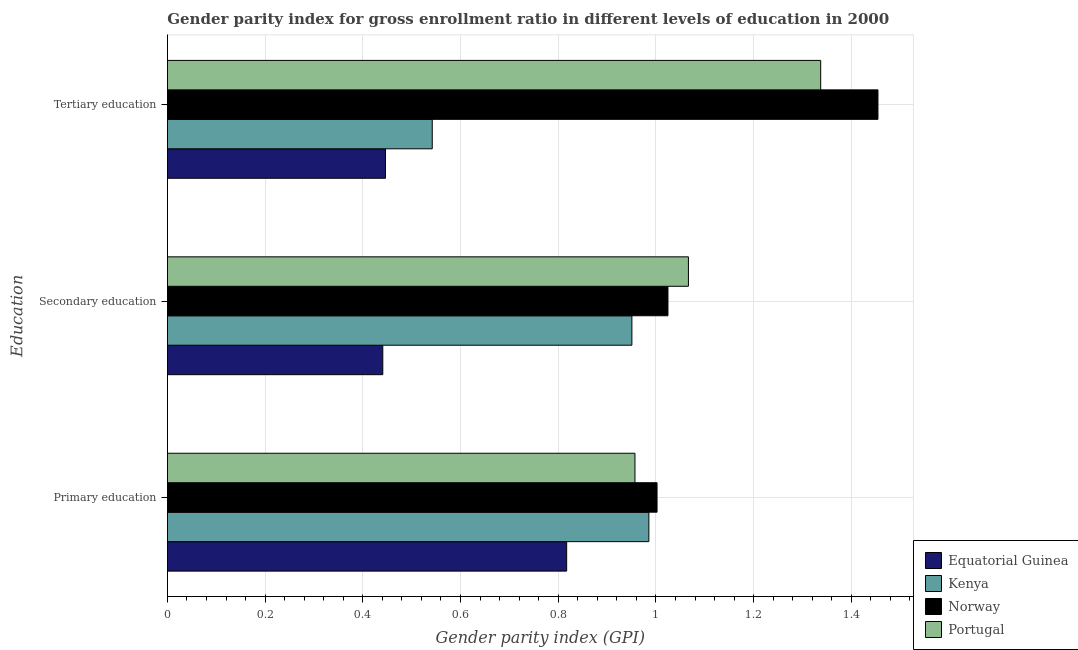How many different coloured bars are there?
Keep it short and to the point. 4. How many groups of bars are there?
Keep it short and to the point. 3. Are the number of bars per tick equal to the number of legend labels?
Keep it short and to the point. Yes. Are the number of bars on each tick of the Y-axis equal?
Keep it short and to the point. Yes. How many bars are there on the 1st tick from the top?
Your answer should be compact. 4. How many bars are there on the 1st tick from the bottom?
Provide a succinct answer. 4. What is the label of the 1st group of bars from the top?
Offer a very short reply. Tertiary education. What is the gender parity index in tertiary education in Portugal?
Provide a short and direct response. 1.34. Across all countries, what is the maximum gender parity index in tertiary education?
Offer a very short reply. 1.45. Across all countries, what is the minimum gender parity index in tertiary education?
Offer a very short reply. 0.45. In which country was the gender parity index in secondary education maximum?
Your response must be concise. Portugal. In which country was the gender parity index in primary education minimum?
Your answer should be compact. Equatorial Guinea. What is the total gender parity index in tertiary education in the graph?
Ensure brevity in your answer.  3.78. What is the difference between the gender parity index in primary education in Equatorial Guinea and that in Portugal?
Ensure brevity in your answer.  -0.14. What is the difference between the gender parity index in tertiary education in Kenya and the gender parity index in primary education in Norway?
Give a very brief answer. -0.46. What is the average gender parity index in secondary education per country?
Your response must be concise. 0.87. What is the difference between the gender parity index in secondary education and gender parity index in tertiary education in Portugal?
Keep it short and to the point. -0.27. What is the ratio of the gender parity index in primary education in Portugal to that in Norway?
Offer a terse response. 0.95. Is the gender parity index in secondary education in Norway less than that in Kenya?
Your response must be concise. No. What is the difference between the highest and the second highest gender parity index in primary education?
Make the answer very short. 0.02. What is the difference between the highest and the lowest gender parity index in primary education?
Your answer should be compact. 0.19. In how many countries, is the gender parity index in primary education greater than the average gender parity index in primary education taken over all countries?
Your answer should be compact. 3. Is the sum of the gender parity index in tertiary education in Norway and Equatorial Guinea greater than the maximum gender parity index in secondary education across all countries?
Offer a very short reply. Yes. What does the 4th bar from the top in Secondary education represents?
Make the answer very short. Equatorial Guinea. What does the 4th bar from the bottom in Primary education represents?
Ensure brevity in your answer.  Portugal. How many bars are there?
Your response must be concise. 12. How many countries are there in the graph?
Provide a short and direct response. 4. What is the difference between two consecutive major ticks on the X-axis?
Give a very brief answer. 0.2. Are the values on the major ticks of X-axis written in scientific E-notation?
Ensure brevity in your answer.  No. Does the graph contain any zero values?
Keep it short and to the point. No. Does the graph contain grids?
Your response must be concise. Yes. How many legend labels are there?
Keep it short and to the point. 4. What is the title of the graph?
Make the answer very short. Gender parity index for gross enrollment ratio in different levels of education in 2000. What is the label or title of the X-axis?
Provide a succinct answer. Gender parity index (GPI). What is the label or title of the Y-axis?
Ensure brevity in your answer.  Education. What is the Gender parity index (GPI) of Equatorial Guinea in Primary education?
Keep it short and to the point. 0.82. What is the Gender parity index (GPI) of Kenya in Primary education?
Offer a terse response. 0.99. What is the Gender parity index (GPI) in Norway in Primary education?
Provide a short and direct response. 1. What is the Gender parity index (GPI) of Portugal in Primary education?
Keep it short and to the point. 0.96. What is the Gender parity index (GPI) of Equatorial Guinea in Secondary education?
Offer a terse response. 0.44. What is the Gender parity index (GPI) of Kenya in Secondary education?
Ensure brevity in your answer.  0.95. What is the Gender parity index (GPI) of Norway in Secondary education?
Provide a short and direct response. 1.02. What is the Gender parity index (GPI) in Portugal in Secondary education?
Provide a short and direct response. 1.07. What is the Gender parity index (GPI) in Equatorial Guinea in Tertiary education?
Your response must be concise. 0.45. What is the Gender parity index (GPI) of Kenya in Tertiary education?
Provide a succinct answer. 0.54. What is the Gender parity index (GPI) of Norway in Tertiary education?
Your response must be concise. 1.45. What is the Gender parity index (GPI) in Portugal in Tertiary education?
Your answer should be compact. 1.34. Across all Education, what is the maximum Gender parity index (GPI) of Equatorial Guinea?
Ensure brevity in your answer.  0.82. Across all Education, what is the maximum Gender parity index (GPI) of Kenya?
Ensure brevity in your answer.  0.99. Across all Education, what is the maximum Gender parity index (GPI) of Norway?
Give a very brief answer. 1.45. Across all Education, what is the maximum Gender parity index (GPI) in Portugal?
Ensure brevity in your answer.  1.34. Across all Education, what is the minimum Gender parity index (GPI) in Equatorial Guinea?
Provide a short and direct response. 0.44. Across all Education, what is the minimum Gender parity index (GPI) in Kenya?
Provide a short and direct response. 0.54. Across all Education, what is the minimum Gender parity index (GPI) in Norway?
Your answer should be compact. 1. Across all Education, what is the minimum Gender parity index (GPI) of Portugal?
Give a very brief answer. 0.96. What is the total Gender parity index (GPI) of Equatorial Guinea in the graph?
Your answer should be very brief. 1.7. What is the total Gender parity index (GPI) in Kenya in the graph?
Give a very brief answer. 2.48. What is the total Gender parity index (GPI) of Norway in the graph?
Your answer should be very brief. 3.48. What is the total Gender parity index (GPI) in Portugal in the graph?
Give a very brief answer. 3.36. What is the difference between the Gender parity index (GPI) of Equatorial Guinea in Primary education and that in Secondary education?
Give a very brief answer. 0.38. What is the difference between the Gender parity index (GPI) in Kenya in Primary education and that in Secondary education?
Give a very brief answer. 0.03. What is the difference between the Gender parity index (GPI) in Norway in Primary education and that in Secondary education?
Offer a terse response. -0.02. What is the difference between the Gender parity index (GPI) in Portugal in Primary education and that in Secondary education?
Provide a short and direct response. -0.11. What is the difference between the Gender parity index (GPI) in Equatorial Guinea in Primary education and that in Tertiary education?
Give a very brief answer. 0.37. What is the difference between the Gender parity index (GPI) of Kenya in Primary education and that in Tertiary education?
Provide a succinct answer. 0.44. What is the difference between the Gender parity index (GPI) in Norway in Primary education and that in Tertiary education?
Make the answer very short. -0.45. What is the difference between the Gender parity index (GPI) in Portugal in Primary education and that in Tertiary education?
Your response must be concise. -0.38. What is the difference between the Gender parity index (GPI) of Equatorial Guinea in Secondary education and that in Tertiary education?
Ensure brevity in your answer.  -0.01. What is the difference between the Gender parity index (GPI) in Kenya in Secondary education and that in Tertiary education?
Make the answer very short. 0.41. What is the difference between the Gender parity index (GPI) in Norway in Secondary education and that in Tertiary education?
Your response must be concise. -0.43. What is the difference between the Gender parity index (GPI) of Portugal in Secondary education and that in Tertiary education?
Make the answer very short. -0.27. What is the difference between the Gender parity index (GPI) in Equatorial Guinea in Primary education and the Gender parity index (GPI) in Kenya in Secondary education?
Your answer should be compact. -0.13. What is the difference between the Gender parity index (GPI) of Equatorial Guinea in Primary education and the Gender parity index (GPI) of Norway in Secondary education?
Provide a succinct answer. -0.21. What is the difference between the Gender parity index (GPI) of Equatorial Guinea in Primary education and the Gender parity index (GPI) of Portugal in Secondary education?
Offer a terse response. -0.25. What is the difference between the Gender parity index (GPI) in Kenya in Primary education and the Gender parity index (GPI) in Norway in Secondary education?
Keep it short and to the point. -0.04. What is the difference between the Gender parity index (GPI) in Kenya in Primary education and the Gender parity index (GPI) in Portugal in Secondary education?
Keep it short and to the point. -0.08. What is the difference between the Gender parity index (GPI) in Norway in Primary education and the Gender parity index (GPI) in Portugal in Secondary education?
Provide a succinct answer. -0.06. What is the difference between the Gender parity index (GPI) in Equatorial Guinea in Primary education and the Gender parity index (GPI) in Kenya in Tertiary education?
Ensure brevity in your answer.  0.28. What is the difference between the Gender parity index (GPI) in Equatorial Guinea in Primary education and the Gender parity index (GPI) in Norway in Tertiary education?
Your answer should be very brief. -0.64. What is the difference between the Gender parity index (GPI) in Equatorial Guinea in Primary education and the Gender parity index (GPI) in Portugal in Tertiary education?
Your answer should be compact. -0.52. What is the difference between the Gender parity index (GPI) in Kenya in Primary education and the Gender parity index (GPI) in Norway in Tertiary education?
Provide a short and direct response. -0.47. What is the difference between the Gender parity index (GPI) of Kenya in Primary education and the Gender parity index (GPI) of Portugal in Tertiary education?
Offer a terse response. -0.35. What is the difference between the Gender parity index (GPI) of Norway in Primary education and the Gender parity index (GPI) of Portugal in Tertiary education?
Ensure brevity in your answer.  -0.34. What is the difference between the Gender parity index (GPI) in Equatorial Guinea in Secondary education and the Gender parity index (GPI) in Kenya in Tertiary education?
Provide a succinct answer. -0.1. What is the difference between the Gender parity index (GPI) of Equatorial Guinea in Secondary education and the Gender parity index (GPI) of Norway in Tertiary education?
Offer a very short reply. -1.01. What is the difference between the Gender parity index (GPI) in Equatorial Guinea in Secondary education and the Gender parity index (GPI) in Portugal in Tertiary education?
Your response must be concise. -0.9. What is the difference between the Gender parity index (GPI) of Kenya in Secondary education and the Gender parity index (GPI) of Norway in Tertiary education?
Your answer should be very brief. -0.5. What is the difference between the Gender parity index (GPI) in Kenya in Secondary education and the Gender parity index (GPI) in Portugal in Tertiary education?
Offer a very short reply. -0.39. What is the difference between the Gender parity index (GPI) of Norway in Secondary education and the Gender parity index (GPI) of Portugal in Tertiary education?
Ensure brevity in your answer.  -0.31. What is the average Gender parity index (GPI) in Equatorial Guinea per Education?
Provide a succinct answer. 0.57. What is the average Gender parity index (GPI) in Kenya per Education?
Keep it short and to the point. 0.83. What is the average Gender parity index (GPI) in Norway per Education?
Offer a terse response. 1.16. What is the average Gender parity index (GPI) of Portugal per Education?
Provide a short and direct response. 1.12. What is the difference between the Gender parity index (GPI) in Equatorial Guinea and Gender parity index (GPI) in Kenya in Primary education?
Your answer should be very brief. -0.17. What is the difference between the Gender parity index (GPI) in Equatorial Guinea and Gender parity index (GPI) in Norway in Primary education?
Offer a very short reply. -0.18. What is the difference between the Gender parity index (GPI) of Equatorial Guinea and Gender parity index (GPI) of Portugal in Primary education?
Provide a succinct answer. -0.14. What is the difference between the Gender parity index (GPI) of Kenya and Gender parity index (GPI) of Norway in Primary education?
Ensure brevity in your answer.  -0.02. What is the difference between the Gender parity index (GPI) in Kenya and Gender parity index (GPI) in Portugal in Primary education?
Ensure brevity in your answer.  0.03. What is the difference between the Gender parity index (GPI) in Norway and Gender parity index (GPI) in Portugal in Primary education?
Keep it short and to the point. 0.05. What is the difference between the Gender parity index (GPI) of Equatorial Guinea and Gender parity index (GPI) of Kenya in Secondary education?
Your response must be concise. -0.51. What is the difference between the Gender parity index (GPI) in Equatorial Guinea and Gender parity index (GPI) in Norway in Secondary education?
Provide a succinct answer. -0.58. What is the difference between the Gender parity index (GPI) in Equatorial Guinea and Gender parity index (GPI) in Portugal in Secondary education?
Give a very brief answer. -0.63. What is the difference between the Gender parity index (GPI) in Kenya and Gender parity index (GPI) in Norway in Secondary education?
Ensure brevity in your answer.  -0.07. What is the difference between the Gender parity index (GPI) of Kenya and Gender parity index (GPI) of Portugal in Secondary education?
Offer a very short reply. -0.12. What is the difference between the Gender parity index (GPI) of Norway and Gender parity index (GPI) of Portugal in Secondary education?
Give a very brief answer. -0.04. What is the difference between the Gender parity index (GPI) in Equatorial Guinea and Gender parity index (GPI) in Kenya in Tertiary education?
Your answer should be very brief. -0.1. What is the difference between the Gender parity index (GPI) in Equatorial Guinea and Gender parity index (GPI) in Norway in Tertiary education?
Your answer should be compact. -1.01. What is the difference between the Gender parity index (GPI) in Equatorial Guinea and Gender parity index (GPI) in Portugal in Tertiary education?
Your answer should be compact. -0.89. What is the difference between the Gender parity index (GPI) in Kenya and Gender parity index (GPI) in Norway in Tertiary education?
Provide a short and direct response. -0.91. What is the difference between the Gender parity index (GPI) of Kenya and Gender parity index (GPI) of Portugal in Tertiary education?
Offer a very short reply. -0.8. What is the difference between the Gender parity index (GPI) of Norway and Gender parity index (GPI) of Portugal in Tertiary education?
Your response must be concise. 0.12. What is the ratio of the Gender parity index (GPI) of Equatorial Guinea in Primary education to that in Secondary education?
Offer a very short reply. 1.85. What is the ratio of the Gender parity index (GPI) of Kenya in Primary education to that in Secondary education?
Keep it short and to the point. 1.04. What is the ratio of the Gender parity index (GPI) of Norway in Primary education to that in Secondary education?
Keep it short and to the point. 0.98. What is the ratio of the Gender parity index (GPI) in Portugal in Primary education to that in Secondary education?
Offer a terse response. 0.9. What is the ratio of the Gender parity index (GPI) of Equatorial Guinea in Primary education to that in Tertiary education?
Ensure brevity in your answer.  1.83. What is the ratio of the Gender parity index (GPI) in Kenya in Primary education to that in Tertiary education?
Keep it short and to the point. 1.82. What is the ratio of the Gender parity index (GPI) of Norway in Primary education to that in Tertiary education?
Keep it short and to the point. 0.69. What is the ratio of the Gender parity index (GPI) of Portugal in Primary education to that in Tertiary education?
Ensure brevity in your answer.  0.72. What is the ratio of the Gender parity index (GPI) in Equatorial Guinea in Secondary education to that in Tertiary education?
Offer a terse response. 0.99. What is the ratio of the Gender parity index (GPI) in Kenya in Secondary education to that in Tertiary education?
Make the answer very short. 1.75. What is the ratio of the Gender parity index (GPI) of Norway in Secondary education to that in Tertiary education?
Offer a terse response. 0.7. What is the ratio of the Gender parity index (GPI) in Portugal in Secondary education to that in Tertiary education?
Your response must be concise. 0.8. What is the difference between the highest and the second highest Gender parity index (GPI) in Equatorial Guinea?
Offer a very short reply. 0.37. What is the difference between the highest and the second highest Gender parity index (GPI) of Kenya?
Your answer should be very brief. 0.03. What is the difference between the highest and the second highest Gender parity index (GPI) in Norway?
Offer a very short reply. 0.43. What is the difference between the highest and the second highest Gender parity index (GPI) in Portugal?
Provide a short and direct response. 0.27. What is the difference between the highest and the lowest Gender parity index (GPI) in Equatorial Guinea?
Keep it short and to the point. 0.38. What is the difference between the highest and the lowest Gender parity index (GPI) in Kenya?
Offer a very short reply. 0.44. What is the difference between the highest and the lowest Gender parity index (GPI) of Norway?
Give a very brief answer. 0.45. What is the difference between the highest and the lowest Gender parity index (GPI) in Portugal?
Offer a very short reply. 0.38. 